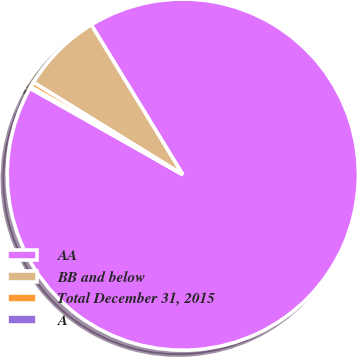Convert chart to OTSL. <chart><loc_0><loc_0><loc_500><loc_500><pie_chart><fcel>AA<fcel>BB and below<fcel>Total December 31, 2015<fcel>A<nl><fcel>91.92%<fcel>7.46%<fcel>0.46%<fcel>0.16%<nl></chart> 